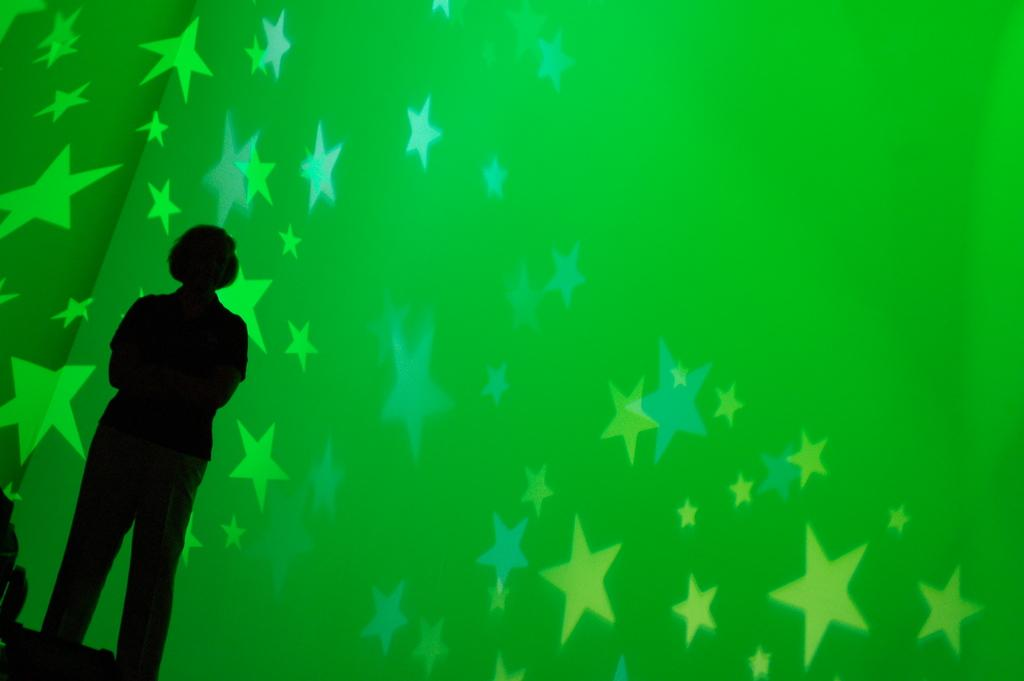What is the main subject of the image? There is a person standing in the center of the image. What can be seen in the background of the image? There is a wall and lights visible in the background of the image. How much money is the person holding in the image? There is no indication of money in the image; the person is not holding any visible objects. 